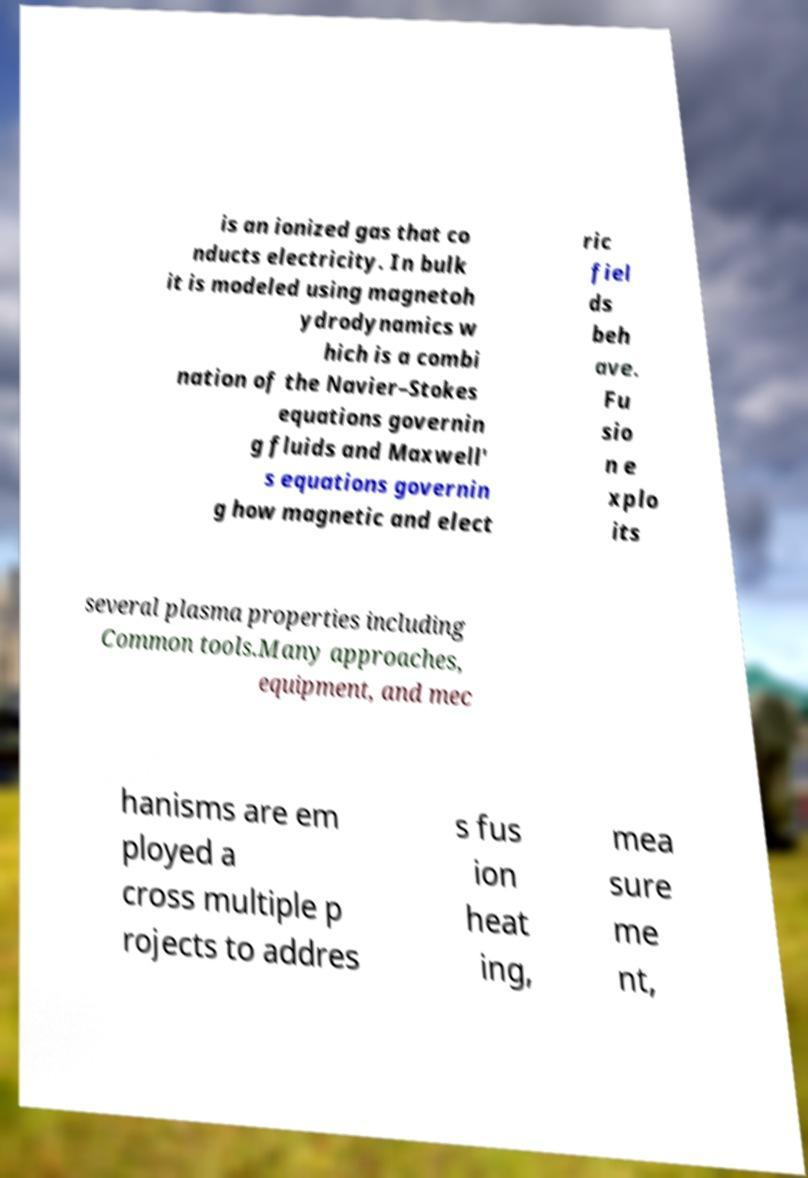Please read and relay the text visible in this image. What does it say? is an ionized gas that co nducts electricity. In bulk it is modeled using magnetoh ydrodynamics w hich is a combi nation of the Navier–Stokes equations governin g fluids and Maxwell' s equations governin g how magnetic and elect ric fiel ds beh ave. Fu sio n e xplo its several plasma properties including Common tools.Many approaches, equipment, and mec hanisms are em ployed a cross multiple p rojects to addres s fus ion heat ing, mea sure me nt, 